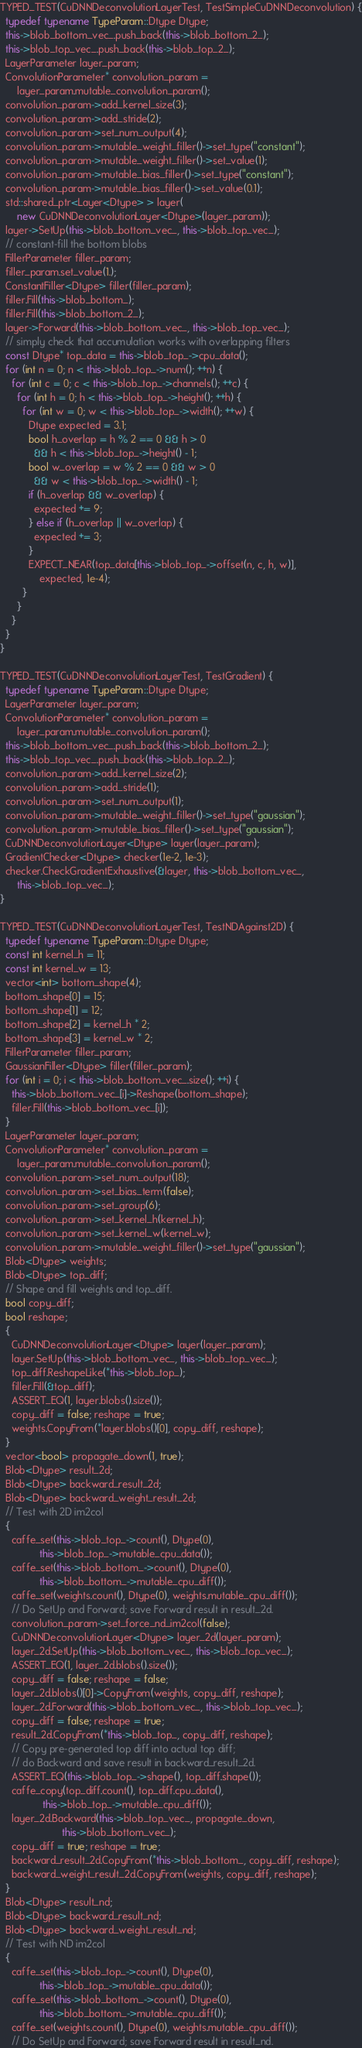Convert code to text. <code><loc_0><loc_0><loc_500><loc_500><_C++_>TYPED_TEST(CuDNNDeconvolutionLayerTest, TestSimpleCuDNNDeconvolution) {
  typedef typename TypeParam::Dtype Dtype;
  this->blob_bottom_vec_.push_back(this->blob_bottom_2_);
  this->blob_top_vec_.push_back(this->blob_top_2_);
  LayerParameter layer_param;
  ConvolutionParameter* convolution_param =
      layer_param.mutable_convolution_param();
  convolution_param->add_kernel_size(3);
  convolution_param->add_stride(2);
  convolution_param->set_num_output(4);
  convolution_param->mutable_weight_filler()->set_type("constant");
  convolution_param->mutable_weight_filler()->set_value(1);
  convolution_param->mutable_bias_filler()->set_type("constant");
  convolution_param->mutable_bias_filler()->set_value(0.1);
  std::shared_ptr<Layer<Dtype> > layer(
      new CuDNNDeconvolutionLayer<Dtype>(layer_param));
  layer->SetUp(this->blob_bottom_vec_, this->blob_top_vec_);
  // constant-fill the bottom blobs
  FillerParameter filler_param;
  filler_param.set_value(1.);
  ConstantFiller<Dtype> filler(filler_param);
  filler.Fill(this->blob_bottom_);
  filler.Fill(this->blob_bottom_2_);
  layer->Forward(this->blob_bottom_vec_, this->blob_top_vec_);
  // simply check that accumulation works with overlapping filters
  const Dtype* top_data = this->blob_top_->cpu_data();
  for (int n = 0; n < this->blob_top_->num(); ++n) {
    for (int c = 0; c < this->blob_top_->channels(); ++c) {
      for (int h = 0; h < this->blob_top_->height(); ++h) {
        for (int w = 0; w < this->blob_top_->width(); ++w) {
          Dtype expected = 3.1;
          bool h_overlap = h % 2 == 0 && h > 0
            && h < this->blob_top_->height() - 1;
          bool w_overlap = w % 2 == 0 && w > 0
            && w < this->blob_top_->width() - 1;
          if (h_overlap && w_overlap) {
            expected += 9;
          } else if (h_overlap || w_overlap) {
            expected += 3;
          }
          EXPECT_NEAR(top_data[this->blob_top_->offset(n, c, h, w)],
              expected, 1e-4);
        }
      }
    }
  }
}

TYPED_TEST(CuDNNDeconvolutionLayerTest, TestGradient) {
  typedef typename TypeParam::Dtype Dtype;
  LayerParameter layer_param;
  ConvolutionParameter* convolution_param =
      layer_param.mutable_convolution_param();
  this->blob_bottom_vec_.push_back(this->blob_bottom_2_);
  this->blob_top_vec_.push_back(this->blob_top_2_);
  convolution_param->add_kernel_size(2);
  convolution_param->add_stride(1);
  convolution_param->set_num_output(1);
  convolution_param->mutable_weight_filler()->set_type("gaussian");
  convolution_param->mutable_bias_filler()->set_type("gaussian");
  CuDNNDeconvolutionLayer<Dtype> layer(layer_param);
  GradientChecker<Dtype> checker(1e-2, 1e-3);
  checker.CheckGradientExhaustive(&layer, this->blob_bottom_vec_,
      this->blob_top_vec_);
}

TYPED_TEST(CuDNNDeconvolutionLayerTest, TestNDAgainst2D) {
  typedef typename TypeParam::Dtype Dtype;
  const int kernel_h = 11;
  const int kernel_w = 13;
  vector<int> bottom_shape(4);
  bottom_shape[0] = 15;
  bottom_shape[1] = 12;
  bottom_shape[2] = kernel_h * 2;
  bottom_shape[3] = kernel_w * 2;
  FillerParameter filler_param;
  GaussianFiller<Dtype> filler(filler_param);
  for (int i = 0; i < this->blob_bottom_vec_.size(); ++i) {
    this->blob_bottom_vec_[i]->Reshape(bottom_shape);
    filler.Fill(this->blob_bottom_vec_[i]);
  }
  LayerParameter layer_param;
  ConvolutionParameter* convolution_param =
      layer_param.mutable_convolution_param();
  convolution_param->set_num_output(18);
  convolution_param->set_bias_term(false);
  convolution_param->set_group(6);
  convolution_param->set_kernel_h(kernel_h);
  convolution_param->set_kernel_w(kernel_w);
  convolution_param->mutable_weight_filler()->set_type("gaussian");
  Blob<Dtype> weights;
  Blob<Dtype> top_diff;
  // Shape and fill weights and top_diff.
  bool copy_diff;
  bool reshape;
  {
    CuDNNDeconvolutionLayer<Dtype> layer(layer_param);
    layer.SetUp(this->blob_bottom_vec_, this->blob_top_vec_);
    top_diff.ReshapeLike(*this->blob_top_);
    filler.Fill(&top_diff);
    ASSERT_EQ(1, layer.blobs().size());
    copy_diff = false; reshape = true;
    weights.CopyFrom(*layer.blobs()[0], copy_diff, reshape);
  }
  vector<bool> propagate_down(1, true);
  Blob<Dtype> result_2d;
  Blob<Dtype> backward_result_2d;
  Blob<Dtype> backward_weight_result_2d;
  // Test with 2D im2col
  {
    caffe_set(this->blob_top_->count(), Dtype(0),
              this->blob_top_->mutable_cpu_data());
    caffe_set(this->blob_bottom_->count(), Dtype(0),
              this->blob_bottom_->mutable_cpu_diff());
    caffe_set(weights.count(), Dtype(0), weights.mutable_cpu_diff());
    // Do SetUp and Forward; save Forward result in result_2d.
    convolution_param->set_force_nd_im2col(false);
    CuDNNDeconvolutionLayer<Dtype> layer_2d(layer_param);
    layer_2d.SetUp(this->blob_bottom_vec_, this->blob_top_vec_);
    ASSERT_EQ(1, layer_2d.blobs().size());
    copy_diff = false; reshape = false;
    layer_2d.blobs()[0]->CopyFrom(weights, copy_diff, reshape);
    layer_2d.Forward(this->blob_bottom_vec_, this->blob_top_vec_);
    copy_diff = false; reshape = true;
    result_2d.CopyFrom(*this->blob_top_, copy_diff, reshape);
    // Copy pre-generated top diff into actual top diff;
    // do Backward and save result in backward_result_2d.
    ASSERT_EQ(this->blob_top_->shape(), top_diff.shape());
    caffe_copy(top_diff.count(), top_diff.cpu_data(),
               this->blob_top_->mutable_cpu_diff());
    layer_2d.Backward(this->blob_top_vec_, propagate_down,
                      this->blob_bottom_vec_);
    copy_diff = true; reshape = true;
    backward_result_2d.CopyFrom(*this->blob_bottom_, copy_diff, reshape);
    backward_weight_result_2d.CopyFrom(weights, copy_diff, reshape);
  }
  Blob<Dtype> result_nd;
  Blob<Dtype> backward_result_nd;
  Blob<Dtype> backward_weight_result_nd;
  // Test with ND im2col
  {
    caffe_set(this->blob_top_->count(), Dtype(0),
              this->blob_top_->mutable_cpu_data());
    caffe_set(this->blob_bottom_->count(), Dtype(0),
              this->blob_bottom_->mutable_cpu_diff());
    caffe_set(weights.count(), Dtype(0), weights.mutable_cpu_diff());
    // Do SetUp and Forward; save Forward result in result_nd.</code> 